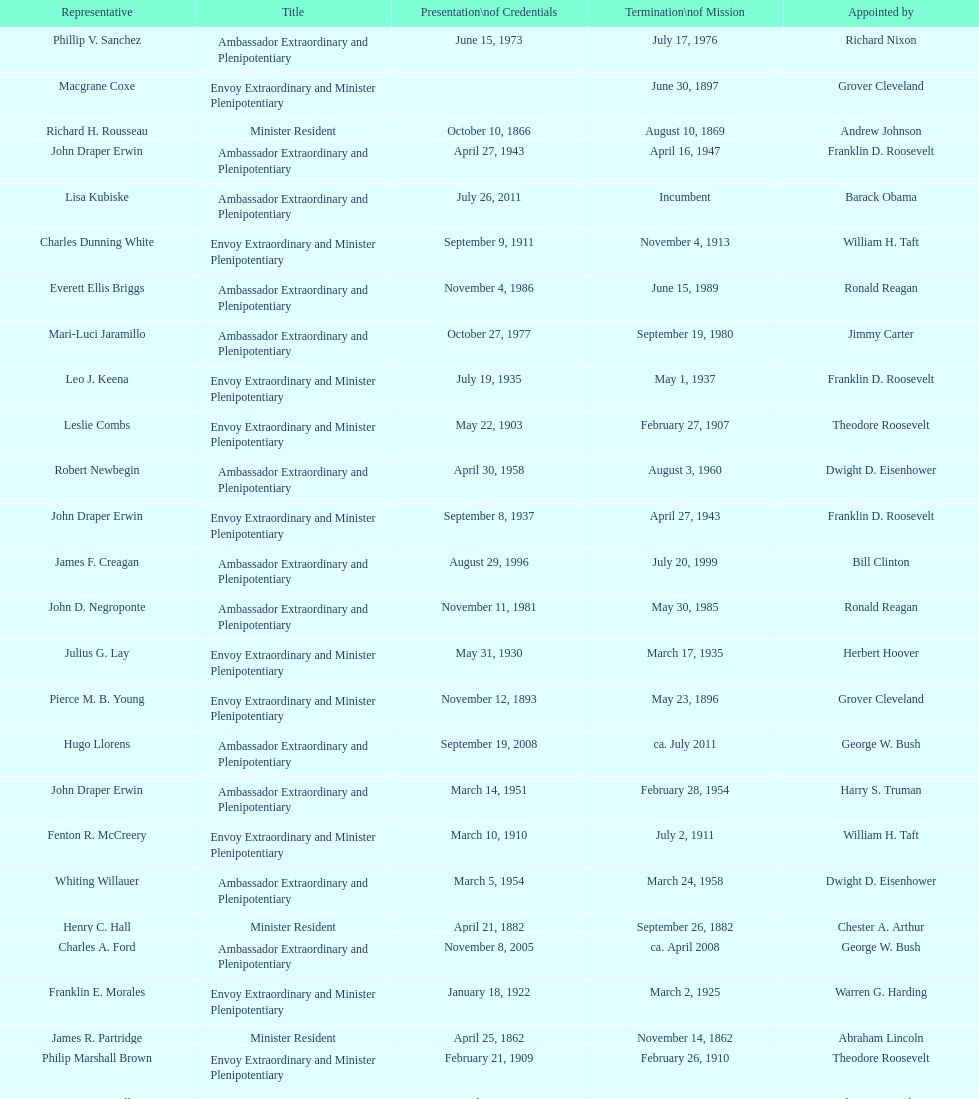Which envoy was the first appointed by woodrow wilson? John Ewing. 